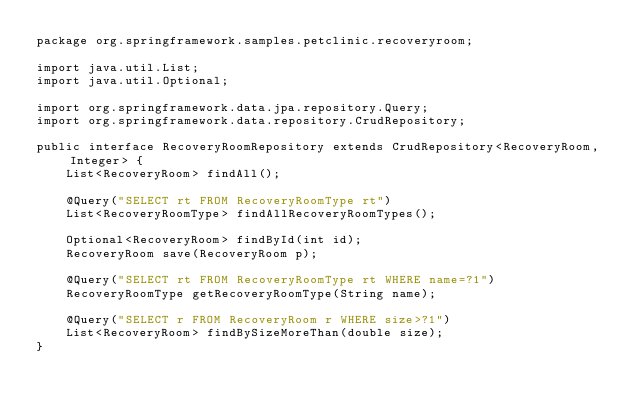<code> <loc_0><loc_0><loc_500><loc_500><_Java_>package org.springframework.samples.petclinic.recoveryroom;

import java.util.List;
import java.util.Optional;

import org.springframework.data.jpa.repository.Query;
import org.springframework.data.repository.CrudRepository;

public interface RecoveryRoomRepository extends CrudRepository<RecoveryRoom, Integer> {
    List<RecoveryRoom> findAll();

    @Query("SELECT rt FROM RecoveryRoomType rt")
    List<RecoveryRoomType> findAllRecoveryRoomTypes();

    Optional<RecoveryRoom> findById(int id);
    RecoveryRoom save(RecoveryRoom p);

    @Query("SELECT rt FROM RecoveryRoomType rt WHERE name=?1")
    RecoveryRoomType getRecoveryRoomType(String name);

    @Query("SELECT r FROM RecoveryRoom r WHERE size>?1")
    List<RecoveryRoom> findBySizeMoreThan(double size);
}
</code> 